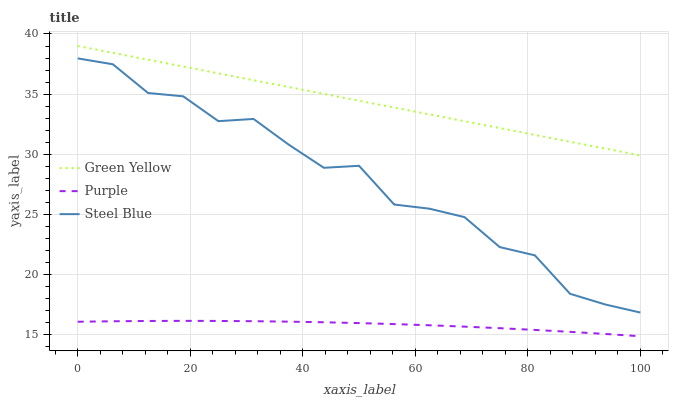Does Purple have the minimum area under the curve?
Answer yes or no. Yes. Does Green Yellow have the maximum area under the curve?
Answer yes or no. Yes. Does Steel Blue have the minimum area under the curve?
Answer yes or no. No. Does Steel Blue have the maximum area under the curve?
Answer yes or no. No. Is Green Yellow the smoothest?
Answer yes or no. Yes. Is Steel Blue the roughest?
Answer yes or no. Yes. Is Steel Blue the smoothest?
Answer yes or no. No. Is Green Yellow the roughest?
Answer yes or no. No. Does Purple have the lowest value?
Answer yes or no. Yes. Does Steel Blue have the lowest value?
Answer yes or no. No. Does Green Yellow have the highest value?
Answer yes or no. Yes. Does Steel Blue have the highest value?
Answer yes or no. No. Is Steel Blue less than Green Yellow?
Answer yes or no. Yes. Is Green Yellow greater than Purple?
Answer yes or no. Yes. Does Steel Blue intersect Green Yellow?
Answer yes or no. No. 